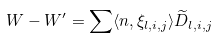<formula> <loc_0><loc_0><loc_500><loc_500>W - W ^ { \prime } = \sum \langle n , \xi _ { l , i , j } \rangle \widetilde { D } _ { l , i , j }</formula> 